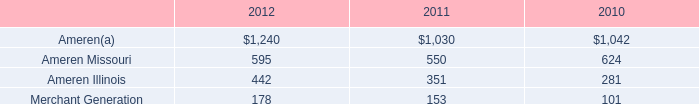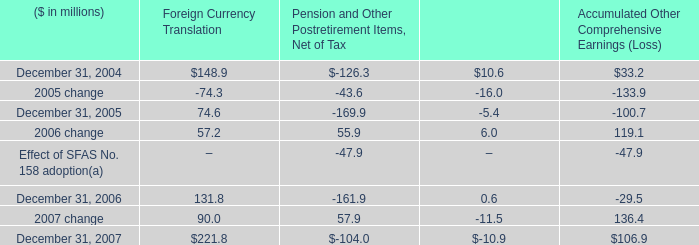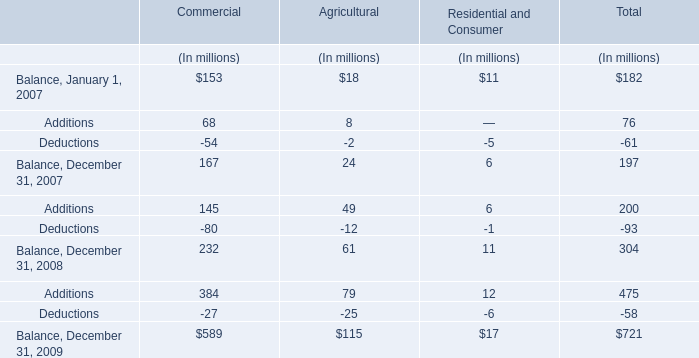In the year with lowest amount of Additions, what's the increasing rate of Deductions for Total? 
Computations: (-61 / -58)
Answer: 1.05172. 